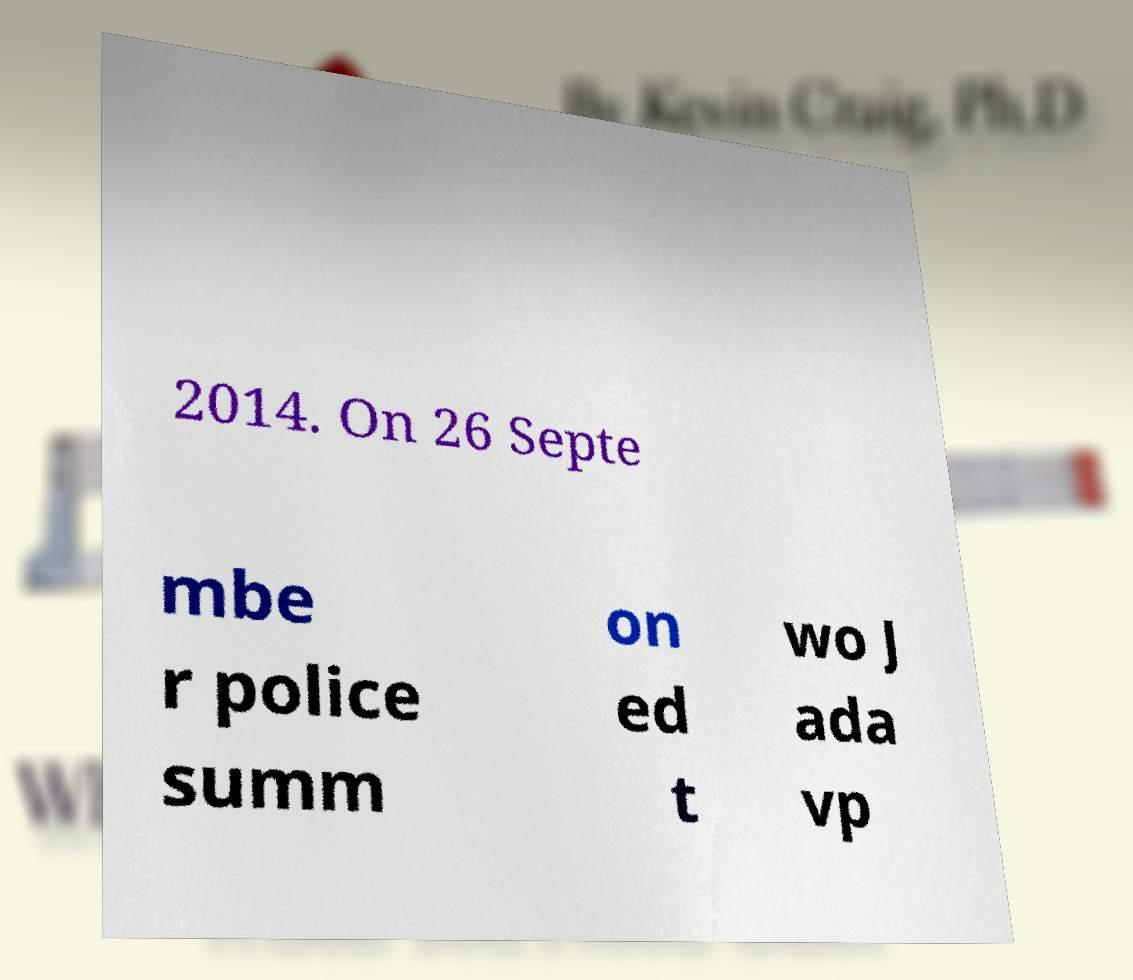For documentation purposes, I need the text within this image transcribed. Could you provide that? 2014. On 26 Septe mbe r police summ on ed t wo J ada vp 